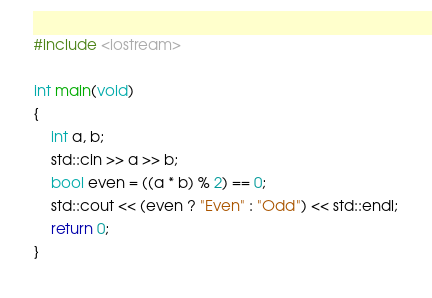<code> <loc_0><loc_0><loc_500><loc_500><_C++_>#include <iostream>

int main(void)
{
    int a, b;
    std::cin >> a >> b;
    bool even = ((a * b) % 2) == 0;
    std::cout << (even ? "Even" : "Odd") << std::endl;
    return 0;
}
</code> 